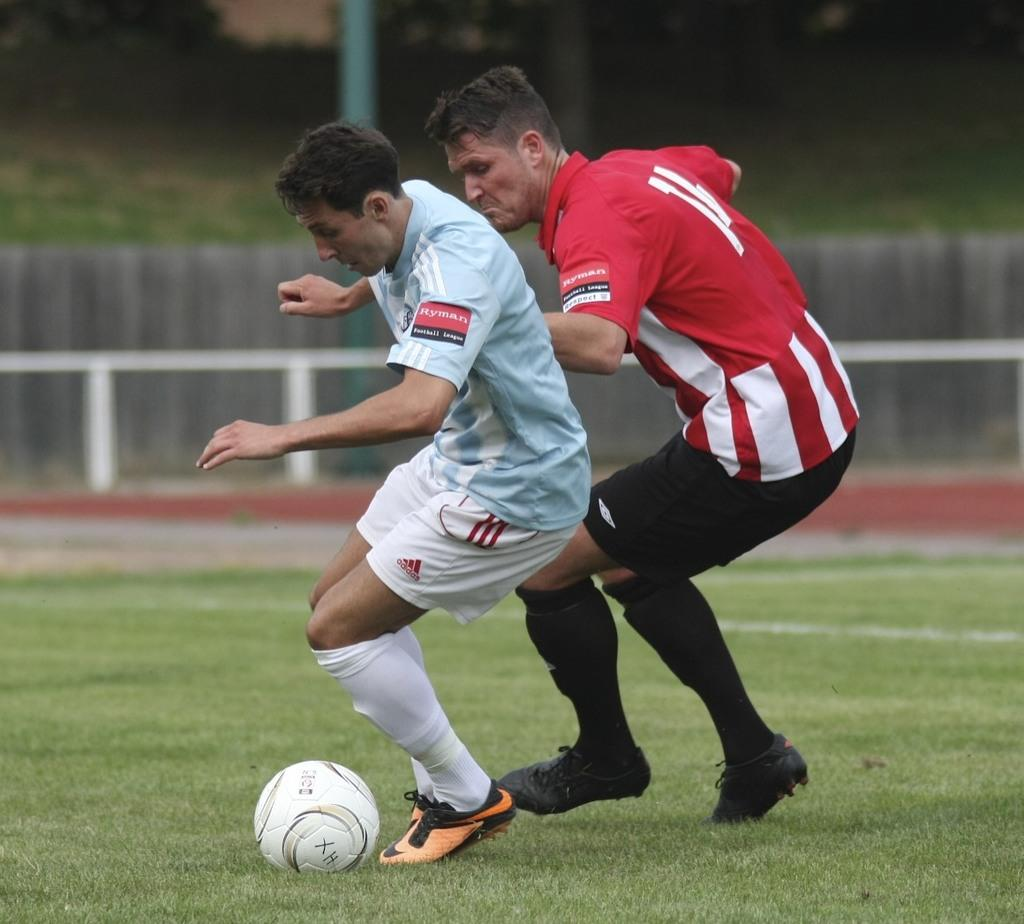What is the main subject of the image? There is a person standing in the image. Can you describe the person in the image? There is a man in the image. What is the man doing in the image? The man is fighting for a ball. What can be seen in the background of the image? There is fencing in the image, and trees are visible above the fencing. What type of calendar is hanging on the fence in the image? There is no calendar present in the image; it features a man fighting for a ball with trees visible above the fencing. Can you see a chain attached to the ball in the image? There is no chain attached to the ball in the image; the man is simply fighting for the ball. 